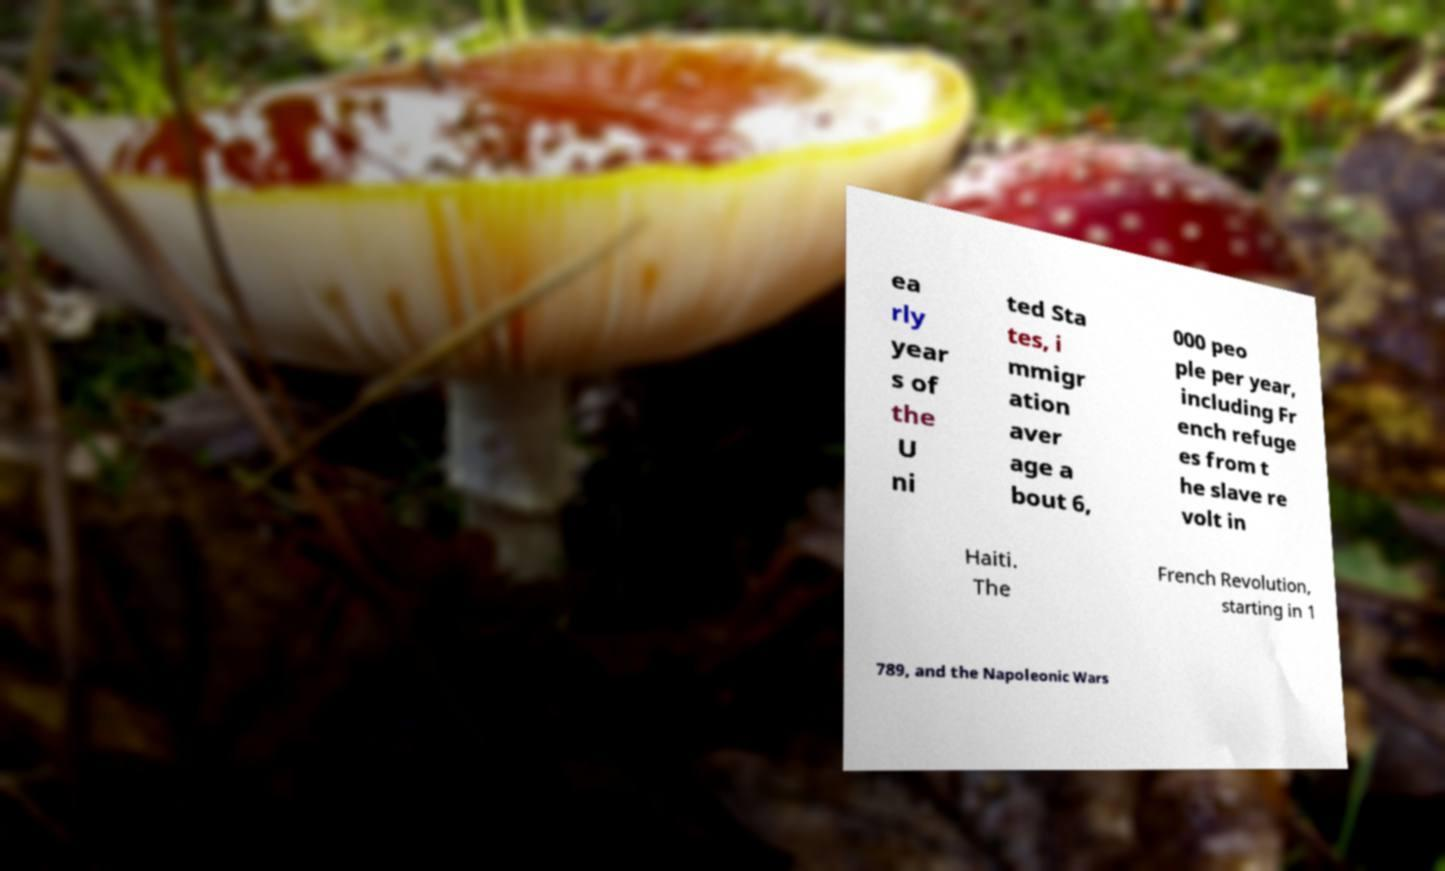Could you assist in decoding the text presented in this image and type it out clearly? ea rly year s of the U ni ted Sta tes, i mmigr ation aver age a bout 6, 000 peo ple per year, including Fr ench refuge es from t he slave re volt in Haiti. The French Revolution, starting in 1 789, and the Napoleonic Wars 